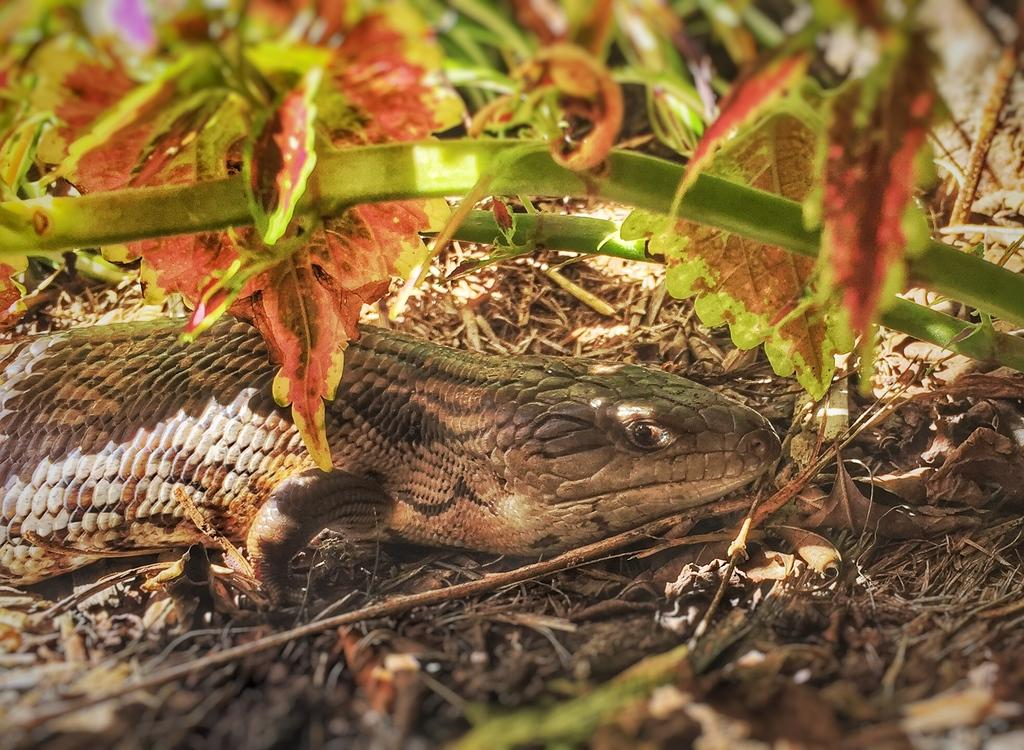What type of animal is in the image? There is a reptile in the image. Where is the reptile located in the image? The reptile is in the middle of the image. What other objects or elements can be seen in the image? There are leaves in the image. How are the leaves positioned in the image? The leaves are in the front of the image. What subject is the reptile teaching in the image? There is no indication in the image that the reptile is teaching any subject. 